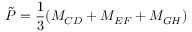Convert formula to latex. <formula><loc_0><loc_0><loc_500><loc_500>\tilde { P } = \frac { 1 } { 3 } ( M _ { C D } + M _ { E F } + M _ { G H } )</formula> 